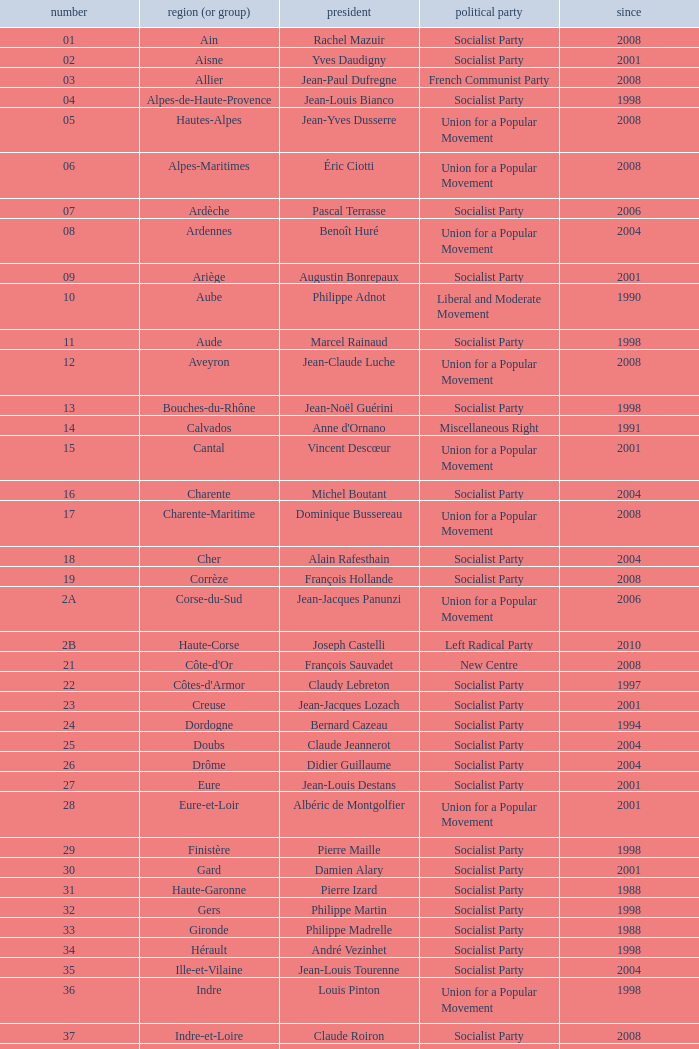Who is the president representing the Creuse department? Jean-Jacques Lozach. 